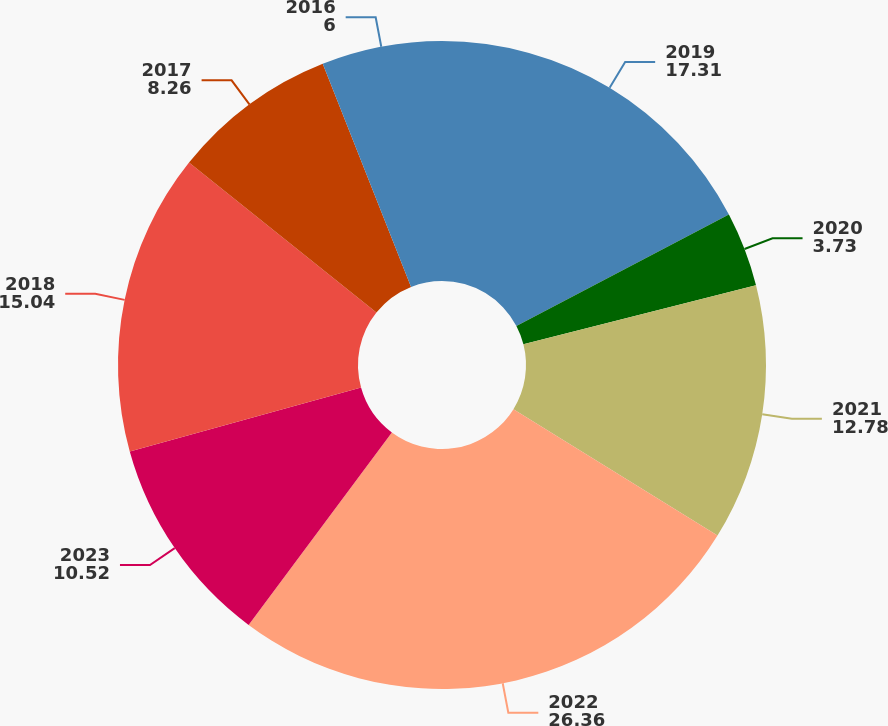Convert chart to OTSL. <chart><loc_0><loc_0><loc_500><loc_500><pie_chart><fcel>2019<fcel>2020<fcel>2021<fcel>2022<fcel>2023<fcel>2018<fcel>2017<fcel>2016<nl><fcel>17.31%<fcel>3.73%<fcel>12.78%<fcel>26.36%<fcel>10.52%<fcel>15.04%<fcel>8.26%<fcel>6.0%<nl></chart> 